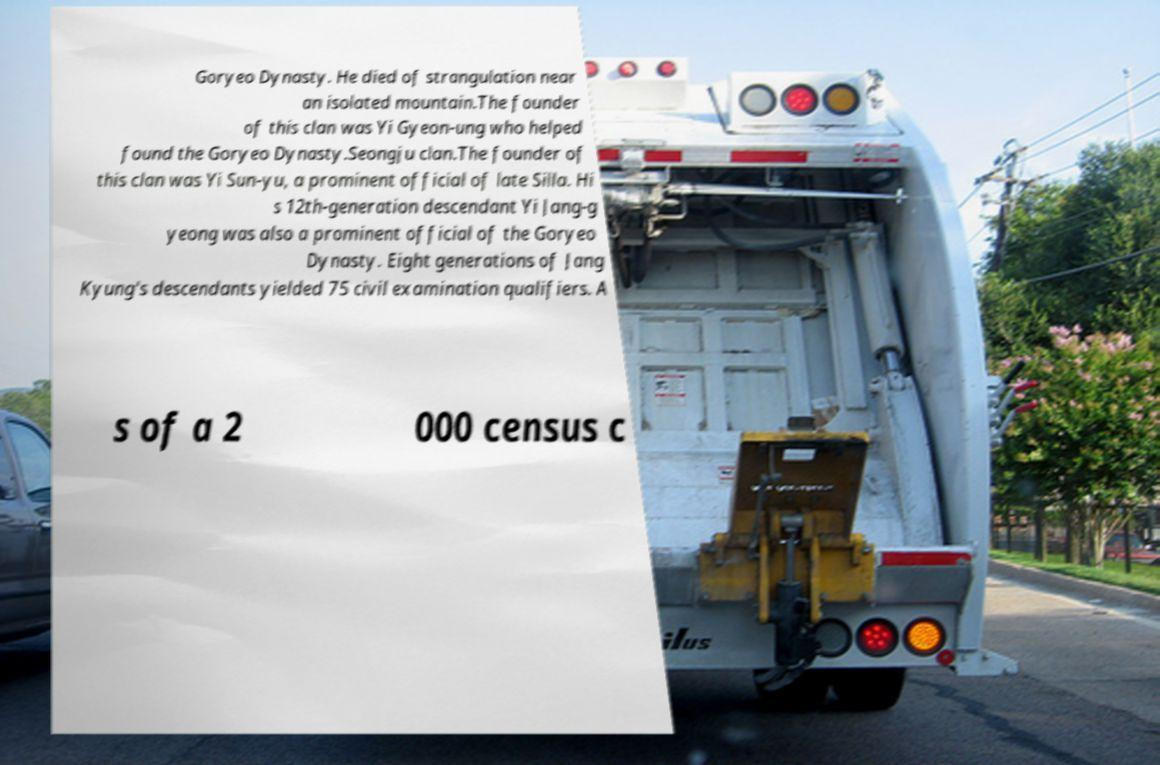Can you accurately transcribe the text from the provided image for me? Goryeo Dynasty. He died of strangulation near an isolated mountain.The founder of this clan was Yi Gyeon-ung who helped found the Goryeo Dynasty.Seongju clan.The founder of this clan was Yi Sun-yu, a prominent official of late Silla. Hi s 12th-generation descendant Yi Jang-g yeong was also a prominent official of the Goryeo Dynasty. Eight generations of Jang Kyung's descendants yielded 75 civil examination qualifiers. A s of a 2 000 census c 